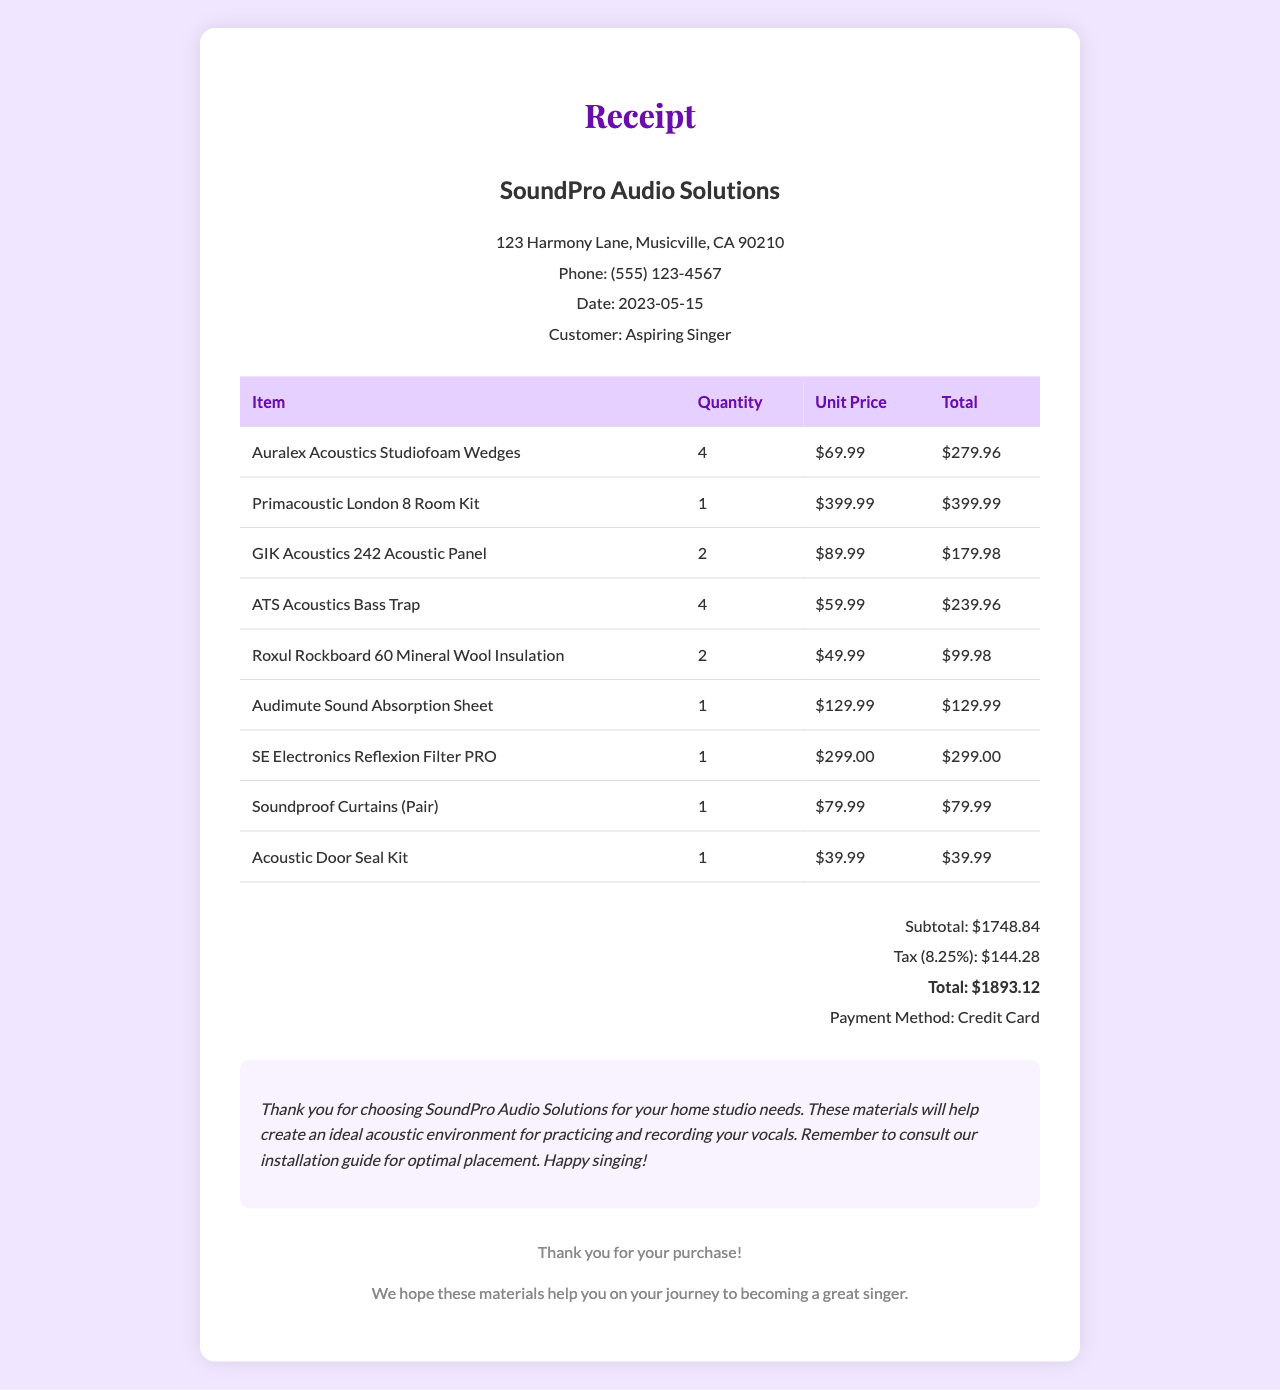What is the store name? The store name is listed at the top of the receipt, which is "SoundPro Audio Solutions."
Answer: SoundPro Audio Solutions What is the date of purchase? The date of purchase is mentioned clearly in the receipt under the date section, which is "2023-05-15."
Answer: 2023-05-15 How many Auralex Acoustics Studiofoam Wedges were purchased? The quantity of Auralex Acoustics Studiofoam Wedges is specified in the items section of the receipt as 4.
Answer: 4 What is the total amount after tax? The total amount after tax is explicitly shown in the totals section as "$1893.12."
Answer: $1893.12 What was the payment method used? The payment method can be found in the totals section, which states "Credit Card."
Answer: Credit Card What is the subtotal before tax? The subtotal before tax is detailed in the totals section of the receipt, which is "$1748.84."
Answer: $1748.84 Which item has the highest unit price? The item with the highest unit price is identified in the items list as "Primacoustic London 8 Room Kit," priced at $399.99.
Answer: Primacoustic London 8 Room Kit What is the tax rate applied in the receipt? The tax rate is given in the totals section as 0.0825, or 8.25%.
Answer: 8.25% How many items did the customer buy in total? The customer bought a total of 8 items as listed in the items section of the receipt.
Answer: 8 